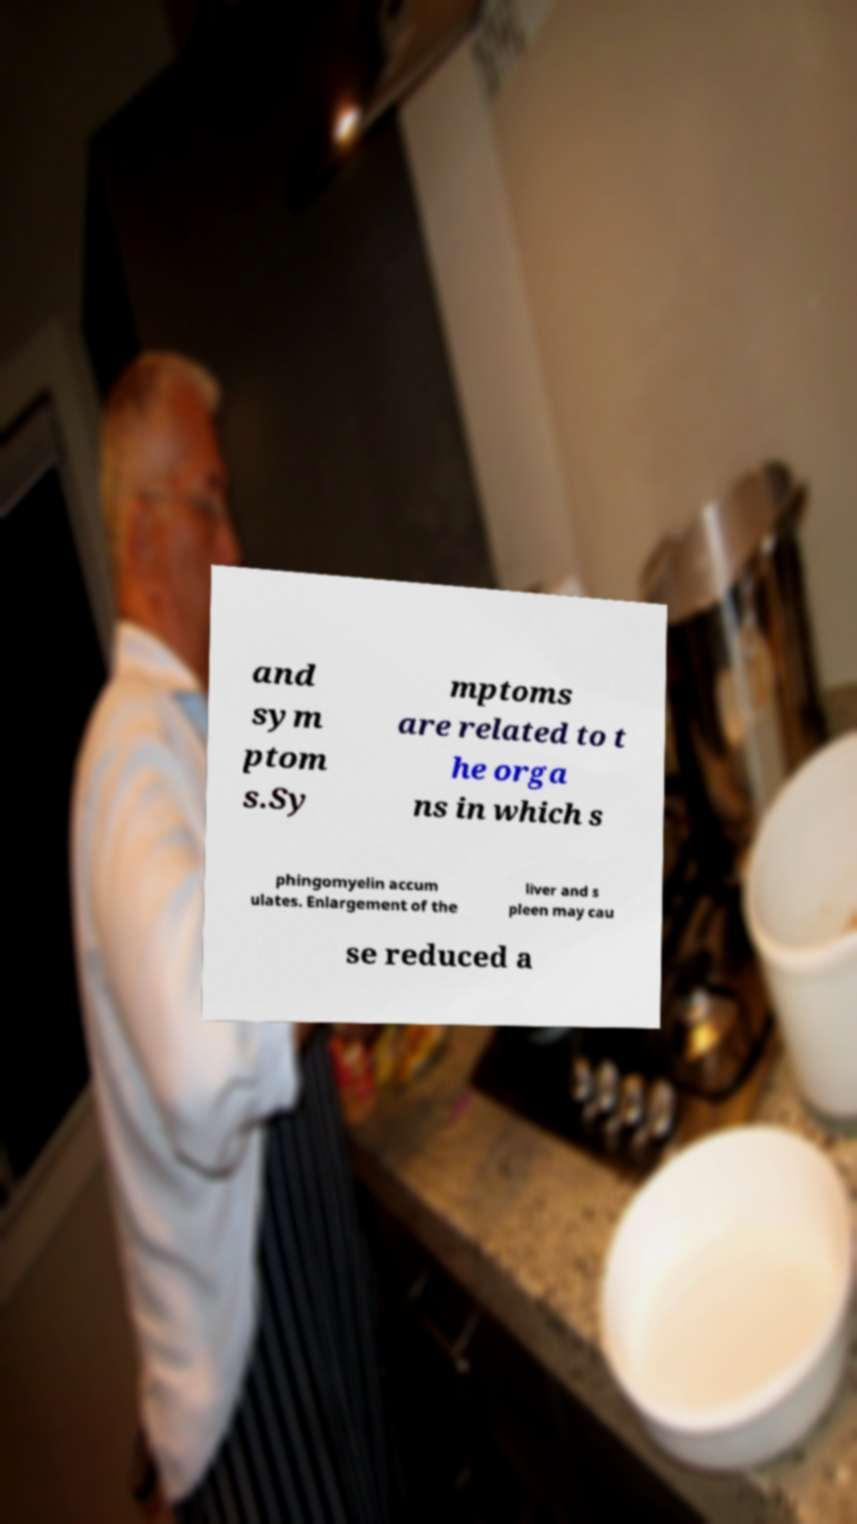There's text embedded in this image that I need extracted. Can you transcribe it verbatim? and sym ptom s.Sy mptoms are related to t he orga ns in which s phingomyelin accum ulates. Enlargement of the liver and s pleen may cau se reduced a 